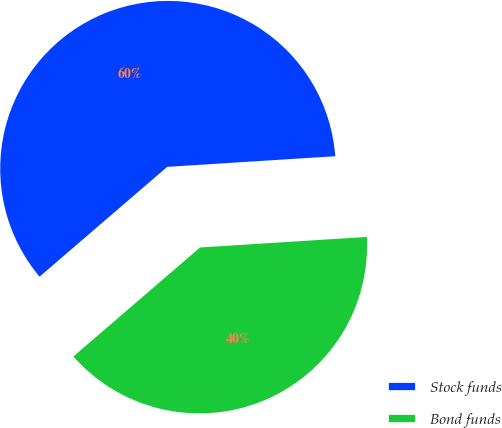Convert chart. <chart><loc_0><loc_0><loc_500><loc_500><pie_chart><fcel>Stock funds<fcel>Bond funds<nl><fcel>60.3%<fcel>39.7%<nl></chart> 